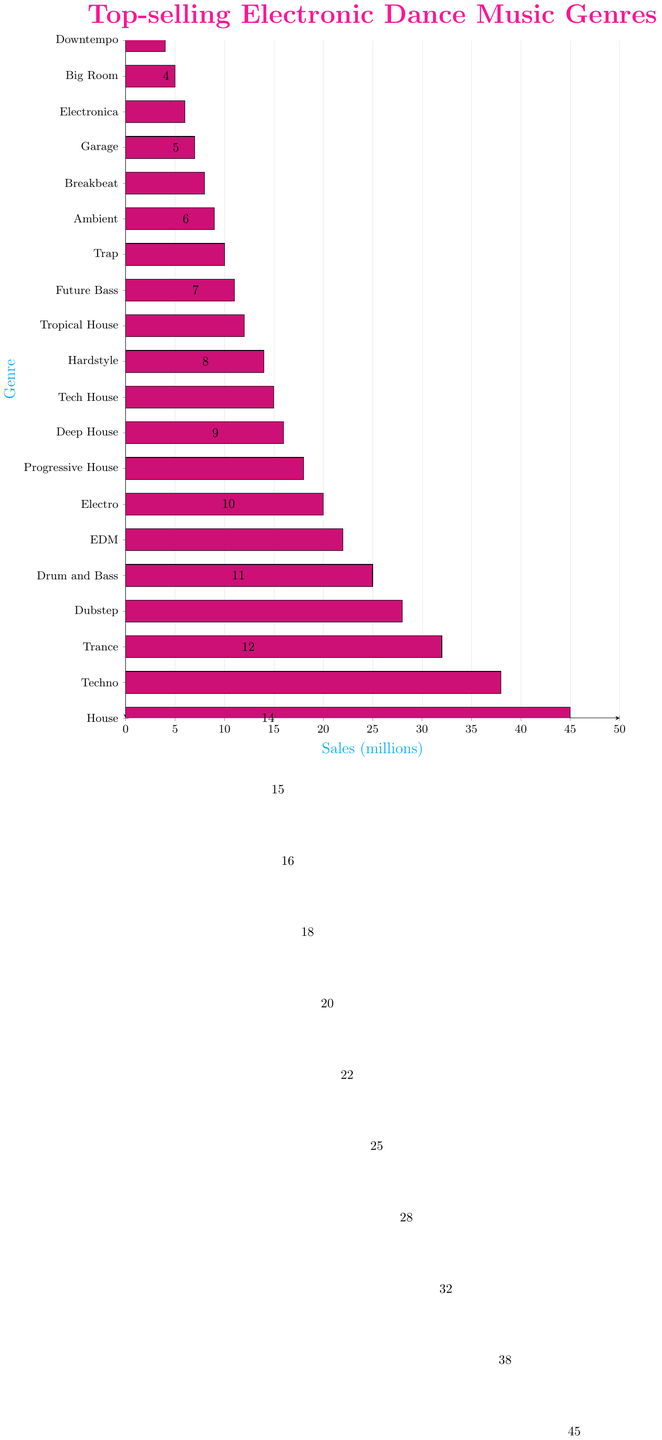Which genre has the highest sales? The bar representing House is the longest, indicating it has the highest sales among all listed genres.
Answer: House What is the total sales of Trance and Techno combined? Trance has sales of 32 million and Techno has sales of 38 million. Adding these together, the total is 32 + 38 = 70 million.
Answer: 70 million Which genre has just slightly higher sales, Ambient or Trap? The bar for Trap is slightly longer than the bar for Ambient, indicating higher sales.
Answer: Trap How many more million sales does Drum and Bass have compared to Electro? Drum and Bass has 25 million sales and Electro has 20 million sales. The difference is 25 - 20 = 5 million.
Answer: 5 million Is the sales difference between House and Techno greater than the combined sales of Big Room and Downtempo? House sales (45 million) minus Techno sales (38 million) is 45 - 38 = 7 million. Combined sales of Big Room (5 million) and Downtempo (4 million) is 5 + 4 = 9 million. Since 7 < 9, the difference is not greater.
Answer: No What is the average sales for Progressive House, Deep House, and Tech House? Sales are 18, 16, and 15 million respectively. Sum is 18 + 16 + 15 = 49 million. Average is 49 / 3 ≈ 16.33 million.
Answer: 16.33 million Which genres have sales between 10 million and 20 million? The genres with bars indicating sales between 10 and 20 million are Tropical House, Future Bass, Trap, Ambient, Breakbeat, Garage, Electronica.
Answer: Tropical House, Future Bass, Trap, Ambient, Breakbeat, Garage, Electronica Compare the sales of Dubstep and EDM. Which one is higher and by how much? Dubstep has 28 million sales and EDM has 22 million sales. The difference is 28 - 22 = 6 million. Dubstep has higher sales by 6 million.
Answer: Dubstep by 6 million 